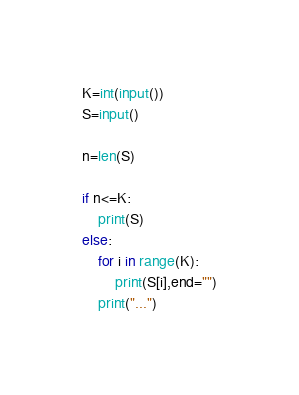<code> <loc_0><loc_0><loc_500><loc_500><_Python_>K=int(input())
S=input()

n=len(S)

if n<=K:
    print(S)
else:
    for i in range(K):
        print(S[i],end="")
    print("...")</code> 